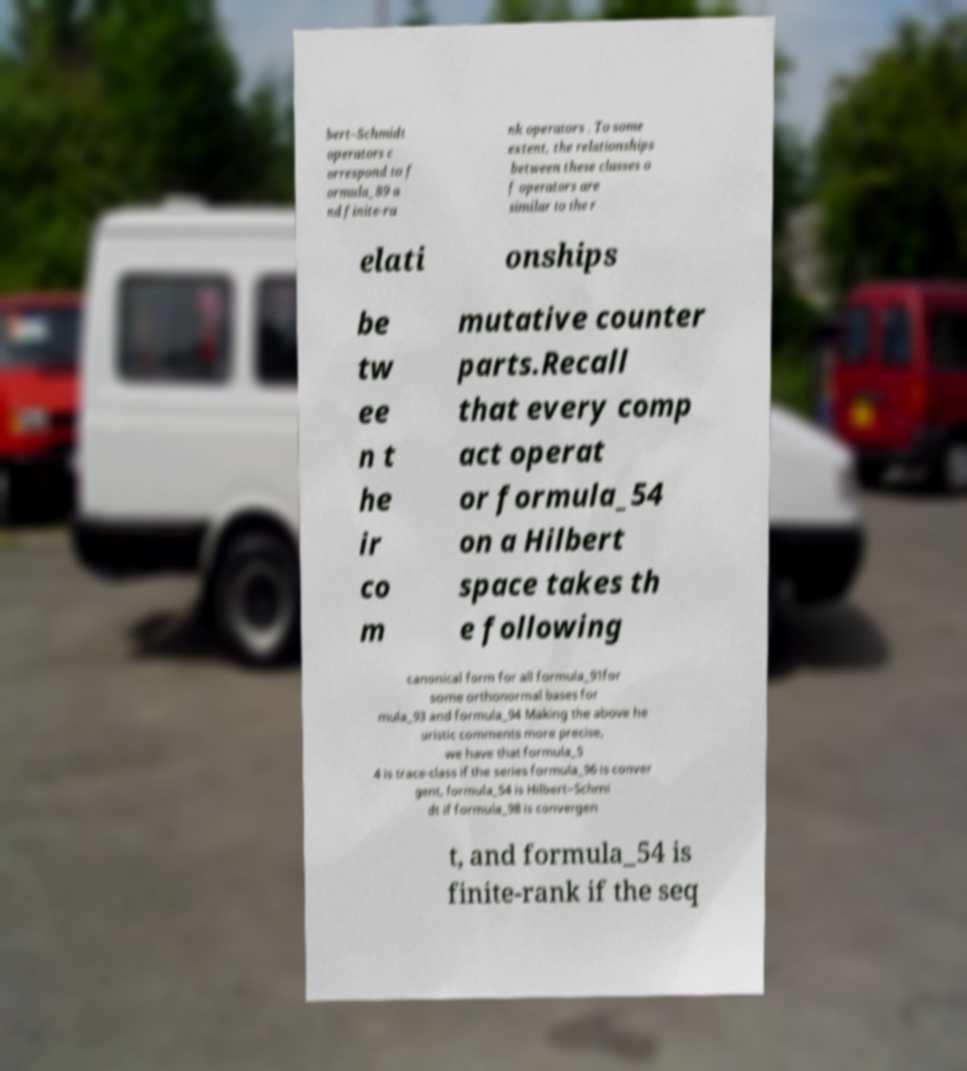Could you extract and type out the text from this image? bert–Schmidt operators c orrespond to f ormula_89 a nd finite-ra nk operators . To some extent, the relationships between these classes o f operators are similar to the r elati onships be tw ee n t he ir co m mutative counter parts.Recall that every comp act operat or formula_54 on a Hilbert space takes th e following canonical form for all formula_91for some orthonormal bases for mula_93 and formula_94 Making the above he uristic comments more precise, we have that formula_5 4 is trace-class if the series formula_96 is conver gent, formula_54 is Hilbert–Schmi dt if formula_98 is convergen t, and formula_54 is finite-rank if the seq 